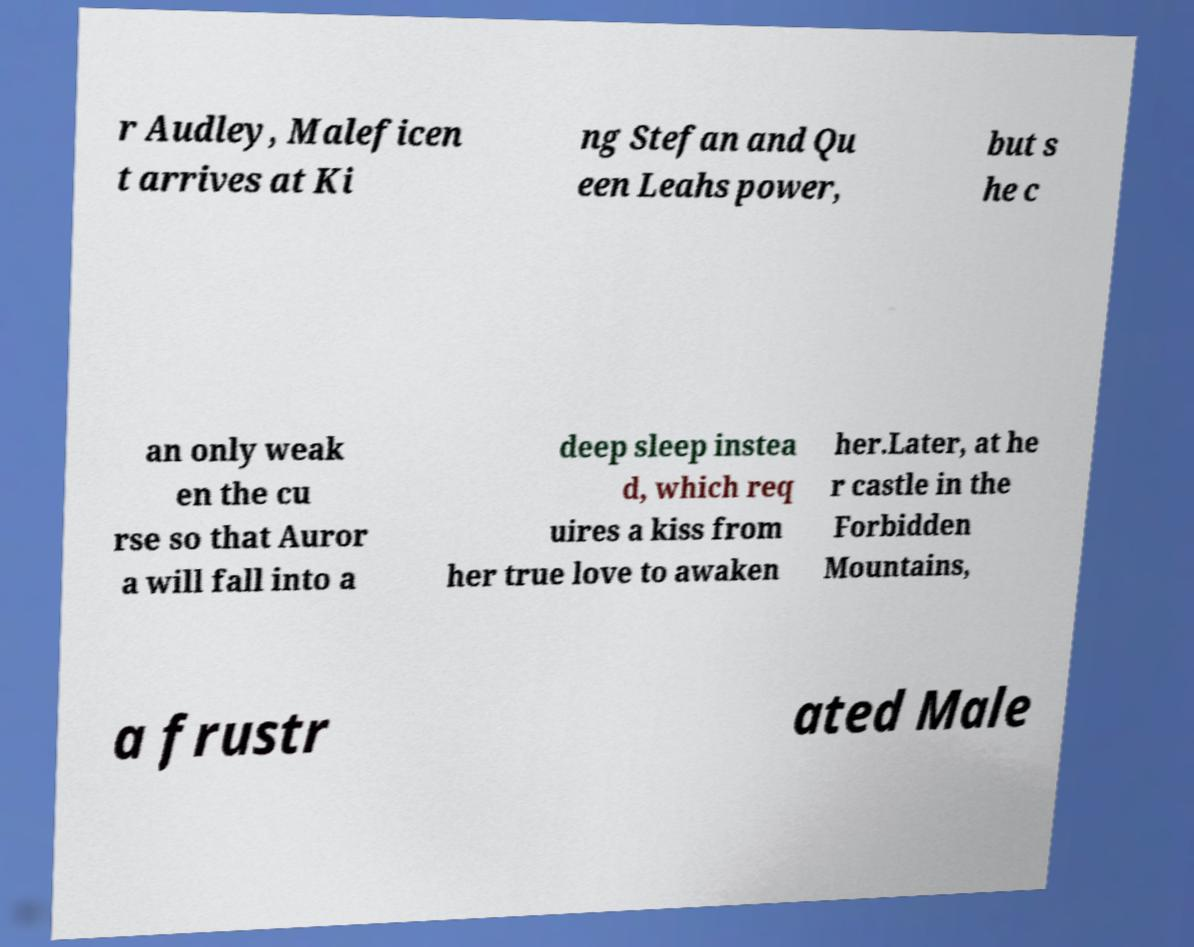Please identify and transcribe the text found in this image. r Audley, Maleficen t arrives at Ki ng Stefan and Qu een Leahs power, but s he c an only weak en the cu rse so that Auror a will fall into a deep sleep instea d, which req uires a kiss from her true love to awaken her.Later, at he r castle in the Forbidden Mountains, a frustr ated Male 